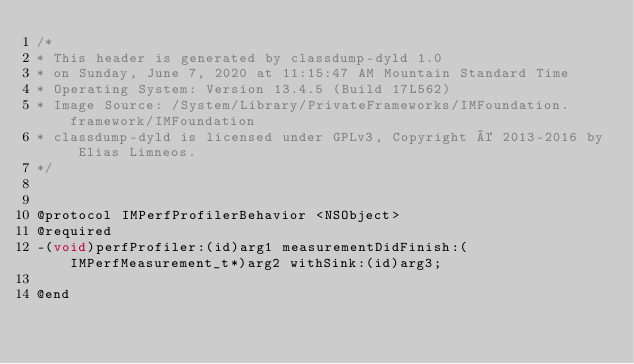Convert code to text. <code><loc_0><loc_0><loc_500><loc_500><_C_>/*
* This header is generated by classdump-dyld 1.0
* on Sunday, June 7, 2020 at 11:15:47 AM Mountain Standard Time
* Operating System: Version 13.4.5 (Build 17L562)
* Image Source: /System/Library/PrivateFrameworks/IMFoundation.framework/IMFoundation
* classdump-dyld is licensed under GPLv3, Copyright © 2013-2016 by Elias Limneos.
*/


@protocol IMPerfProfilerBehavior <NSObject>
@required
-(void)perfProfiler:(id)arg1 measurementDidFinish:(IMPerfMeasurement_t*)arg2 withSink:(id)arg3;

@end

</code> 